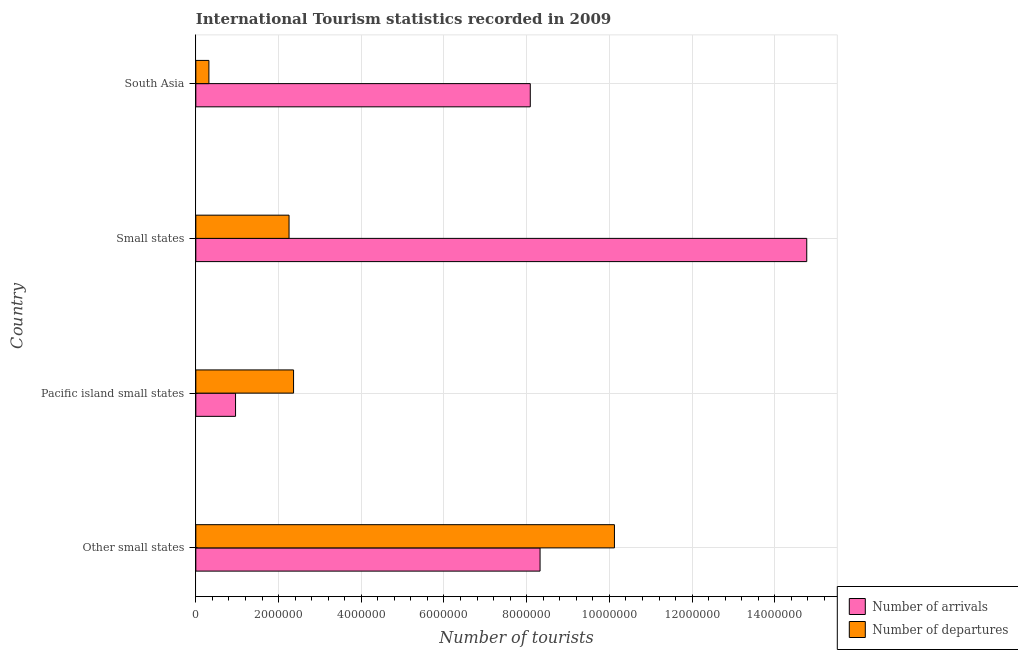How many groups of bars are there?
Your response must be concise. 4. Are the number of bars per tick equal to the number of legend labels?
Keep it short and to the point. Yes. How many bars are there on the 2nd tick from the bottom?
Make the answer very short. 2. What is the label of the 4th group of bars from the top?
Your response must be concise. Other small states. In how many cases, is the number of bars for a given country not equal to the number of legend labels?
Your answer should be very brief. 0. What is the number of tourist departures in South Asia?
Your response must be concise. 3.16e+05. Across all countries, what is the maximum number of tourist arrivals?
Your answer should be very brief. 1.48e+07. Across all countries, what is the minimum number of tourist departures?
Offer a terse response. 3.16e+05. In which country was the number of tourist arrivals maximum?
Your answer should be compact. Small states. In which country was the number of tourist arrivals minimum?
Provide a short and direct response. Pacific island small states. What is the total number of tourist arrivals in the graph?
Ensure brevity in your answer.  3.21e+07. What is the difference between the number of tourist departures in Other small states and that in Small states?
Your response must be concise. 7.87e+06. What is the difference between the number of tourist departures in South Asia and the number of tourist arrivals in Small states?
Your answer should be very brief. -1.45e+07. What is the average number of tourist departures per country?
Give a very brief answer. 3.76e+06. What is the difference between the number of tourist arrivals and number of tourist departures in Small states?
Offer a terse response. 1.25e+07. In how many countries, is the number of tourist arrivals greater than 1600000 ?
Provide a short and direct response. 3. What is the ratio of the number of tourist departures in Other small states to that in Small states?
Ensure brevity in your answer.  4.49. Is the difference between the number of tourist arrivals in Other small states and South Asia greater than the difference between the number of tourist departures in Other small states and South Asia?
Make the answer very short. No. What is the difference between the highest and the second highest number of tourist departures?
Provide a short and direct response. 7.76e+06. What is the difference between the highest and the lowest number of tourist arrivals?
Offer a terse response. 1.38e+07. Is the sum of the number of tourist departures in Other small states and Small states greater than the maximum number of tourist arrivals across all countries?
Provide a short and direct response. No. What does the 1st bar from the top in South Asia represents?
Provide a short and direct response. Number of departures. What does the 2nd bar from the bottom in Small states represents?
Your response must be concise. Number of departures. How many bars are there?
Ensure brevity in your answer.  8. Are all the bars in the graph horizontal?
Offer a terse response. Yes. How many countries are there in the graph?
Your answer should be very brief. 4. Are the values on the major ticks of X-axis written in scientific E-notation?
Provide a short and direct response. No. Does the graph contain any zero values?
Ensure brevity in your answer.  No. Does the graph contain grids?
Your answer should be compact. Yes. Where does the legend appear in the graph?
Make the answer very short. Bottom right. What is the title of the graph?
Make the answer very short. International Tourism statistics recorded in 2009. Does "Secondary" appear as one of the legend labels in the graph?
Provide a short and direct response. No. What is the label or title of the X-axis?
Give a very brief answer. Number of tourists. What is the label or title of the Y-axis?
Give a very brief answer. Country. What is the Number of tourists in Number of arrivals in Other small states?
Give a very brief answer. 8.32e+06. What is the Number of tourists of Number of departures in Other small states?
Your response must be concise. 1.01e+07. What is the Number of tourists of Number of arrivals in Pacific island small states?
Provide a succinct answer. 9.60e+05. What is the Number of tourists of Number of departures in Pacific island small states?
Provide a short and direct response. 2.36e+06. What is the Number of tourists of Number of arrivals in Small states?
Make the answer very short. 1.48e+07. What is the Number of tourists of Number of departures in Small states?
Give a very brief answer. 2.25e+06. What is the Number of tourists of Number of arrivals in South Asia?
Your answer should be very brief. 8.09e+06. What is the Number of tourists of Number of departures in South Asia?
Offer a terse response. 3.16e+05. Across all countries, what is the maximum Number of tourists in Number of arrivals?
Provide a succinct answer. 1.48e+07. Across all countries, what is the maximum Number of tourists in Number of departures?
Ensure brevity in your answer.  1.01e+07. Across all countries, what is the minimum Number of tourists in Number of arrivals?
Provide a short and direct response. 9.60e+05. Across all countries, what is the minimum Number of tourists in Number of departures?
Offer a terse response. 3.16e+05. What is the total Number of tourists of Number of arrivals in the graph?
Offer a very short reply. 3.21e+07. What is the total Number of tourists of Number of departures in the graph?
Offer a very short reply. 1.51e+07. What is the difference between the Number of tourists in Number of arrivals in Other small states and that in Pacific island small states?
Ensure brevity in your answer.  7.36e+06. What is the difference between the Number of tourists in Number of departures in Other small states and that in Pacific island small states?
Keep it short and to the point. 7.76e+06. What is the difference between the Number of tourists in Number of arrivals in Other small states and that in Small states?
Offer a terse response. -6.45e+06. What is the difference between the Number of tourists of Number of departures in Other small states and that in Small states?
Your answer should be compact. 7.87e+06. What is the difference between the Number of tourists in Number of arrivals in Other small states and that in South Asia?
Keep it short and to the point. 2.36e+05. What is the difference between the Number of tourists of Number of departures in Other small states and that in South Asia?
Keep it short and to the point. 9.80e+06. What is the difference between the Number of tourists in Number of arrivals in Pacific island small states and that in Small states?
Your answer should be compact. -1.38e+07. What is the difference between the Number of tourists of Number of departures in Pacific island small states and that in Small states?
Provide a succinct answer. 1.09e+05. What is the difference between the Number of tourists in Number of arrivals in Pacific island small states and that in South Asia?
Offer a very short reply. -7.13e+06. What is the difference between the Number of tourists in Number of departures in Pacific island small states and that in South Asia?
Offer a terse response. 2.05e+06. What is the difference between the Number of tourists of Number of arrivals in Small states and that in South Asia?
Your answer should be compact. 6.68e+06. What is the difference between the Number of tourists in Number of departures in Small states and that in South Asia?
Provide a succinct answer. 1.94e+06. What is the difference between the Number of tourists of Number of arrivals in Other small states and the Number of tourists of Number of departures in Pacific island small states?
Your answer should be compact. 5.96e+06. What is the difference between the Number of tourists of Number of arrivals in Other small states and the Number of tourists of Number of departures in Small states?
Your answer should be compact. 6.07e+06. What is the difference between the Number of tourists in Number of arrivals in Other small states and the Number of tourists in Number of departures in South Asia?
Provide a succinct answer. 8.01e+06. What is the difference between the Number of tourists of Number of arrivals in Pacific island small states and the Number of tourists of Number of departures in Small states?
Your response must be concise. -1.29e+06. What is the difference between the Number of tourists in Number of arrivals in Pacific island small states and the Number of tourists in Number of departures in South Asia?
Give a very brief answer. 6.44e+05. What is the difference between the Number of tourists of Number of arrivals in Small states and the Number of tourists of Number of departures in South Asia?
Make the answer very short. 1.45e+07. What is the average Number of tourists in Number of arrivals per country?
Keep it short and to the point. 8.04e+06. What is the average Number of tourists in Number of departures per country?
Ensure brevity in your answer.  3.76e+06. What is the difference between the Number of tourists of Number of arrivals and Number of tourists of Number of departures in Other small states?
Your response must be concise. -1.80e+06. What is the difference between the Number of tourists in Number of arrivals and Number of tourists in Number of departures in Pacific island small states?
Provide a short and direct response. -1.40e+06. What is the difference between the Number of tourists of Number of arrivals and Number of tourists of Number of departures in Small states?
Provide a short and direct response. 1.25e+07. What is the difference between the Number of tourists in Number of arrivals and Number of tourists in Number of departures in South Asia?
Your answer should be very brief. 7.77e+06. What is the ratio of the Number of tourists in Number of arrivals in Other small states to that in Pacific island small states?
Provide a short and direct response. 8.67. What is the ratio of the Number of tourists in Number of departures in Other small states to that in Pacific island small states?
Keep it short and to the point. 4.28. What is the ratio of the Number of tourists in Number of arrivals in Other small states to that in Small states?
Ensure brevity in your answer.  0.56. What is the ratio of the Number of tourists in Number of departures in Other small states to that in Small states?
Your response must be concise. 4.49. What is the ratio of the Number of tourists in Number of arrivals in Other small states to that in South Asia?
Keep it short and to the point. 1.03. What is the ratio of the Number of tourists in Number of departures in Other small states to that in South Asia?
Ensure brevity in your answer.  32.03. What is the ratio of the Number of tourists of Number of arrivals in Pacific island small states to that in Small states?
Provide a short and direct response. 0.07. What is the ratio of the Number of tourists in Number of departures in Pacific island small states to that in Small states?
Provide a succinct answer. 1.05. What is the ratio of the Number of tourists of Number of arrivals in Pacific island small states to that in South Asia?
Ensure brevity in your answer.  0.12. What is the ratio of the Number of tourists in Number of departures in Pacific island small states to that in South Asia?
Provide a short and direct response. 7.48. What is the ratio of the Number of tourists in Number of arrivals in Small states to that in South Asia?
Make the answer very short. 1.83. What is the ratio of the Number of tourists in Number of departures in Small states to that in South Asia?
Your response must be concise. 7.13. What is the difference between the highest and the second highest Number of tourists in Number of arrivals?
Keep it short and to the point. 6.45e+06. What is the difference between the highest and the second highest Number of tourists in Number of departures?
Make the answer very short. 7.76e+06. What is the difference between the highest and the lowest Number of tourists of Number of arrivals?
Your response must be concise. 1.38e+07. What is the difference between the highest and the lowest Number of tourists of Number of departures?
Offer a terse response. 9.80e+06. 